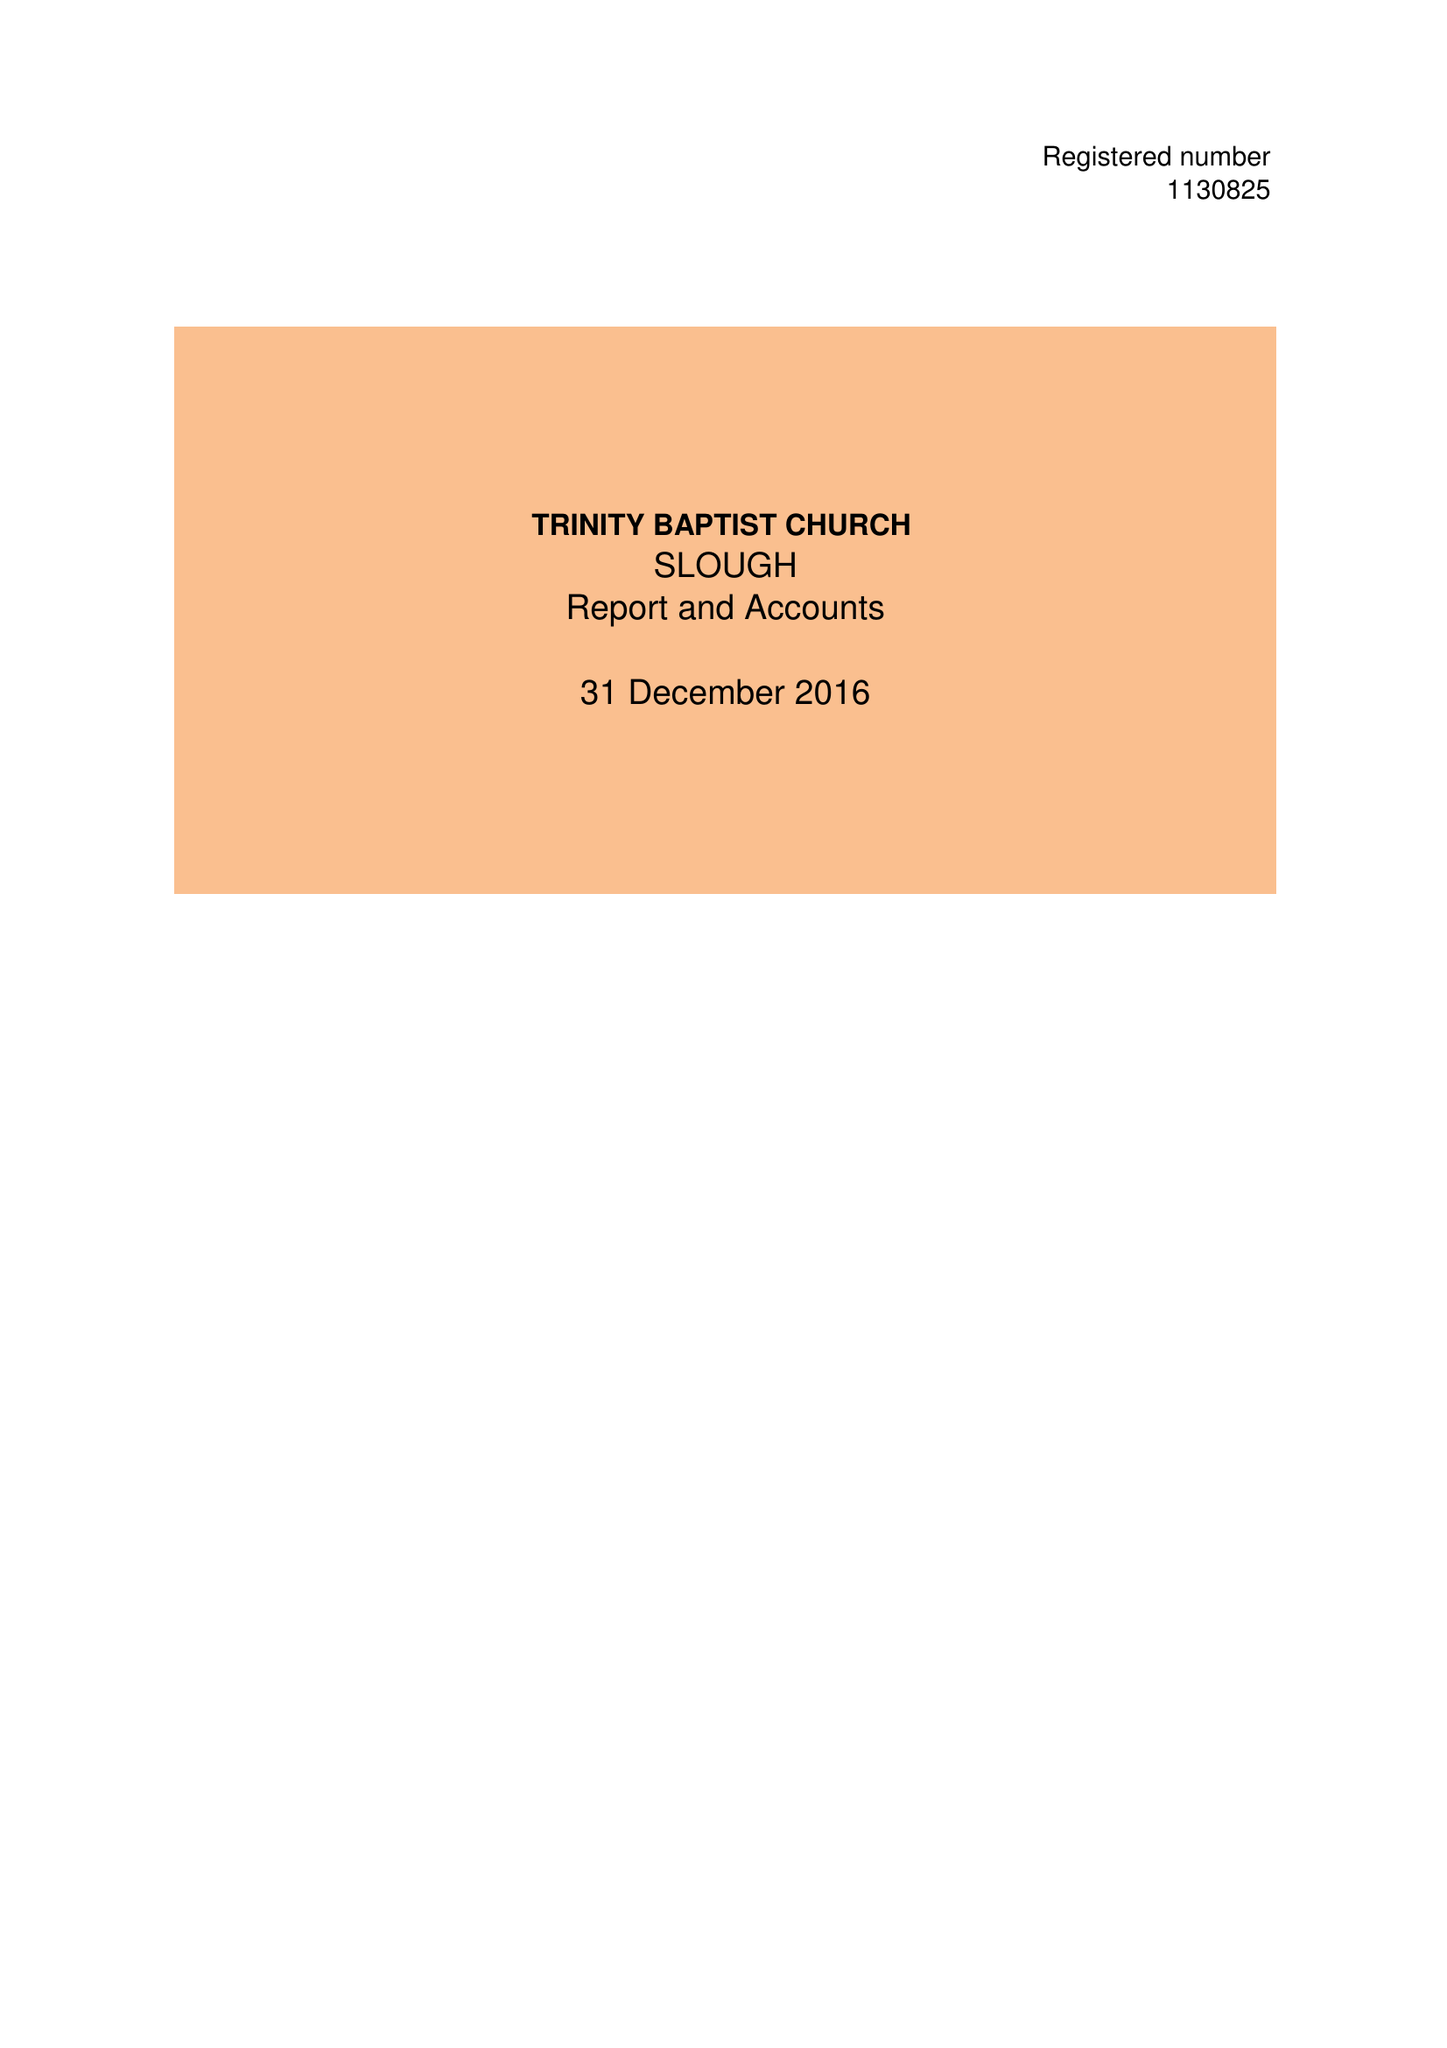What is the value for the address__postcode?
Answer the question using a single word or phrase. CR0 2BQ 